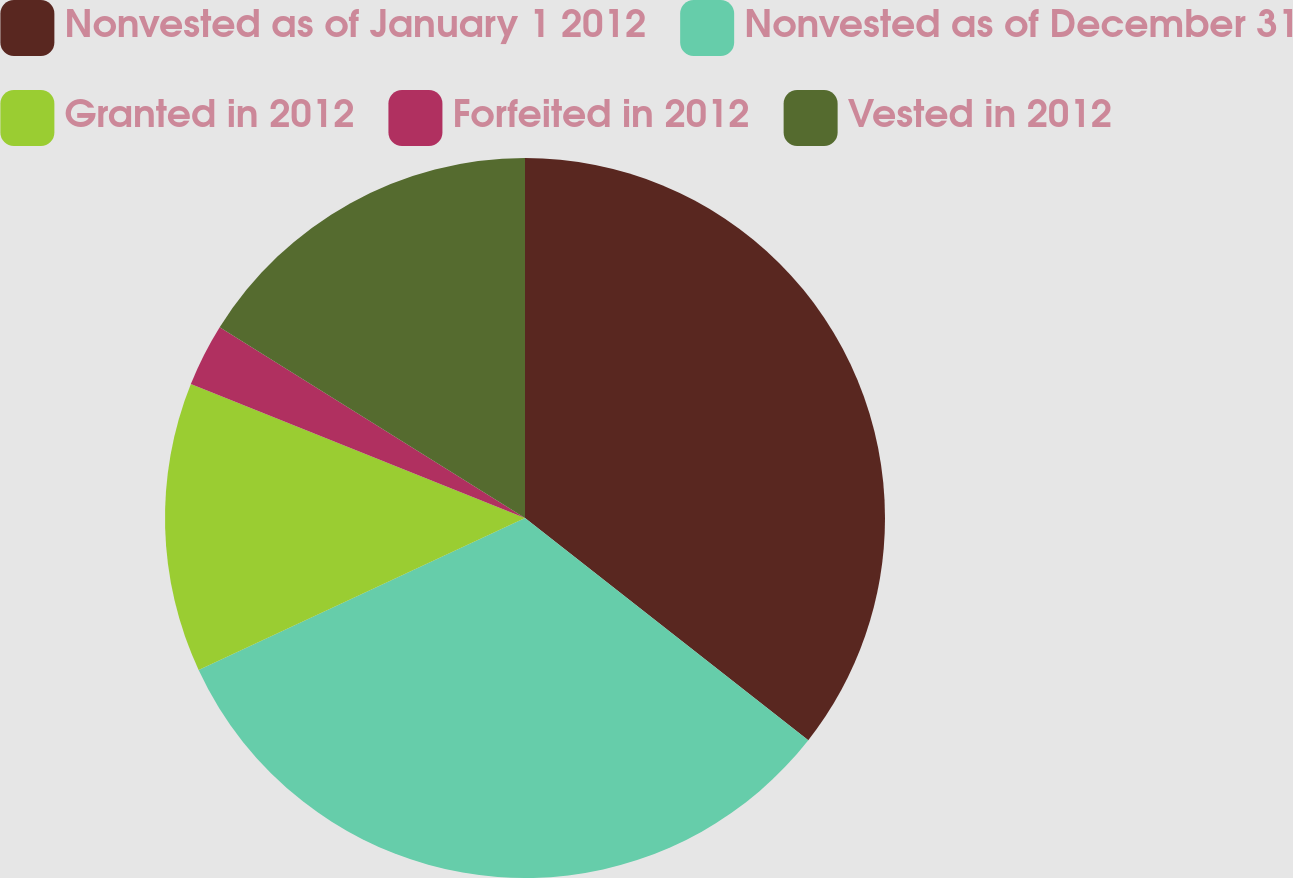Convert chart to OTSL. <chart><loc_0><loc_0><loc_500><loc_500><pie_chart><fcel>Nonvested as of January 1 2012<fcel>Nonvested as of December 31<fcel>Granted in 2012<fcel>Forfeited in 2012<fcel>Vested in 2012<nl><fcel>35.58%<fcel>32.48%<fcel>13.0%<fcel>2.82%<fcel>16.11%<nl></chart> 